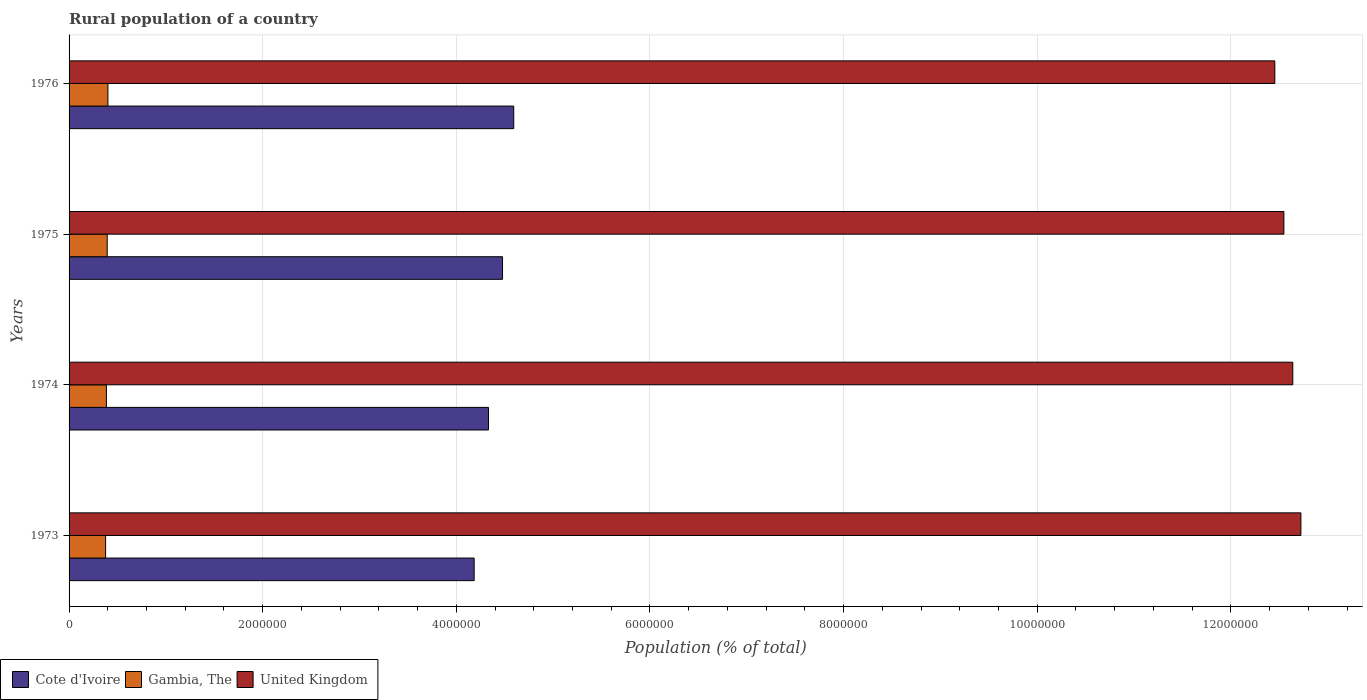How many different coloured bars are there?
Your response must be concise. 3. What is the label of the 3rd group of bars from the top?
Your answer should be very brief. 1974. In how many cases, is the number of bars for a given year not equal to the number of legend labels?
Make the answer very short. 0. What is the rural population in United Kingdom in 1976?
Your response must be concise. 1.25e+07. Across all years, what is the maximum rural population in United Kingdom?
Provide a short and direct response. 1.27e+07. Across all years, what is the minimum rural population in United Kingdom?
Your answer should be compact. 1.25e+07. In which year was the rural population in Cote d'Ivoire maximum?
Give a very brief answer. 1976. What is the total rural population in Gambia, The in the graph?
Provide a short and direct response. 1.56e+06. What is the difference between the rural population in Gambia, The in 1973 and that in 1975?
Offer a very short reply. -1.63e+04. What is the difference between the rural population in Gambia, The in 1976 and the rural population in United Kingdom in 1974?
Your answer should be compact. -1.22e+07. What is the average rural population in Gambia, The per year?
Provide a short and direct response. 3.90e+05. In the year 1976, what is the difference between the rural population in Cote d'Ivoire and rural population in Gambia, The?
Offer a terse response. 4.19e+06. In how many years, is the rural population in Cote d'Ivoire greater than 4800000 %?
Give a very brief answer. 0. What is the ratio of the rural population in Gambia, The in 1973 to that in 1975?
Your answer should be compact. 0.96. Is the rural population in United Kingdom in 1974 less than that in 1976?
Make the answer very short. No. Is the difference between the rural population in Cote d'Ivoire in 1973 and 1976 greater than the difference between the rural population in Gambia, The in 1973 and 1976?
Offer a very short reply. No. What is the difference between the highest and the second highest rural population in Cote d'Ivoire?
Your answer should be very brief. 1.16e+05. What is the difference between the highest and the lowest rural population in United Kingdom?
Keep it short and to the point. 2.69e+05. What does the 2nd bar from the top in 1974 represents?
Give a very brief answer. Gambia, The. What does the 2nd bar from the bottom in 1976 represents?
Keep it short and to the point. Gambia, The. Are all the bars in the graph horizontal?
Make the answer very short. Yes. What is the difference between two consecutive major ticks on the X-axis?
Provide a succinct answer. 2.00e+06. Does the graph contain grids?
Provide a succinct answer. Yes. Where does the legend appear in the graph?
Your response must be concise. Bottom left. How many legend labels are there?
Keep it short and to the point. 3. How are the legend labels stacked?
Offer a very short reply. Horizontal. What is the title of the graph?
Your answer should be very brief. Rural population of a country. What is the label or title of the X-axis?
Ensure brevity in your answer.  Population (% of total). What is the label or title of the Y-axis?
Offer a terse response. Years. What is the Population (% of total) in Cote d'Ivoire in 1973?
Your answer should be very brief. 4.18e+06. What is the Population (% of total) of Gambia, The in 1973?
Ensure brevity in your answer.  3.77e+05. What is the Population (% of total) in United Kingdom in 1973?
Offer a very short reply. 1.27e+07. What is the Population (% of total) of Cote d'Ivoire in 1974?
Make the answer very short. 4.33e+06. What is the Population (% of total) in Gambia, The in 1974?
Keep it short and to the point. 3.86e+05. What is the Population (% of total) of United Kingdom in 1974?
Make the answer very short. 1.26e+07. What is the Population (% of total) of Cote d'Ivoire in 1975?
Ensure brevity in your answer.  4.48e+06. What is the Population (% of total) in Gambia, The in 1975?
Give a very brief answer. 3.94e+05. What is the Population (% of total) of United Kingdom in 1975?
Give a very brief answer. 1.25e+07. What is the Population (% of total) of Cote d'Ivoire in 1976?
Offer a very short reply. 4.59e+06. What is the Population (% of total) in Gambia, The in 1976?
Offer a terse response. 4.01e+05. What is the Population (% of total) of United Kingdom in 1976?
Offer a very short reply. 1.25e+07. Across all years, what is the maximum Population (% of total) in Cote d'Ivoire?
Give a very brief answer. 4.59e+06. Across all years, what is the maximum Population (% of total) of Gambia, The?
Your answer should be compact. 4.01e+05. Across all years, what is the maximum Population (% of total) of United Kingdom?
Your answer should be compact. 1.27e+07. Across all years, what is the minimum Population (% of total) in Cote d'Ivoire?
Make the answer very short. 4.18e+06. Across all years, what is the minimum Population (% of total) of Gambia, The?
Provide a succinct answer. 3.77e+05. Across all years, what is the minimum Population (% of total) in United Kingdom?
Provide a succinct answer. 1.25e+07. What is the total Population (% of total) of Cote d'Ivoire in the graph?
Your answer should be very brief. 1.76e+07. What is the total Population (% of total) of Gambia, The in the graph?
Provide a succinct answer. 1.56e+06. What is the total Population (% of total) in United Kingdom in the graph?
Your answer should be very brief. 5.04e+07. What is the difference between the Population (% of total) in Cote d'Ivoire in 1973 and that in 1974?
Ensure brevity in your answer.  -1.48e+05. What is the difference between the Population (% of total) of Gambia, The in 1973 and that in 1974?
Offer a very short reply. -8351. What is the difference between the Population (% of total) of United Kingdom in 1973 and that in 1974?
Keep it short and to the point. 8.36e+04. What is the difference between the Population (% of total) of Cote d'Ivoire in 1973 and that in 1975?
Provide a succinct answer. -2.93e+05. What is the difference between the Population (% of total) of Gambia, The in 1973 and that in 1975?
Make the answer very short. -1.63e+04. What is the difference between the Population (% of total) of United Kingdom in 1973 and that in 1975?
Offer a very short reply. 1.76e+05. What is the difference between the Population (% of total) in Cote d'Ivoire in 1973 and that in 1976?
Make the answer very short. -4.09e+05. What is the difference between the Population (% of total) of Gambia, The in 1973 and that in 1976?
Your answer should be compact. -2.38e+04. What is the difference between the Population (% of total) of United Kingdom in 1973 and that in 1976?
Your answer should be compact. 2.69e+05. What is the difference between the Population (% of total) in Cote d'Ivoire in 1974 and that in 1975?
Provide a succinct answer. -1.45e+05. What is the difference between the Population (% of total) in Gambia, The in 1974 and that in 1975?
Offer a very short reply. -7961. What is the difference between the Population (% of total) of United Kingdom in 1974 and that in 1975?
Provide a short and direct response. 9.20e+04. What is the difference between the Population (% of total) in Cote d'Ivoire in 1974 and that in 1976?
Ensure brevity in your answer.  -2.61e+05. What is the difference between the Population (% of total) of Gambia, The in 1974 and that in 1976?
Offer a very short reply. -1.54e+04. What is the difference between the Population (% of total) in United Kingdom in 1974 and that in 1976?
Make the answer very short. 1.86e+05. What is the difference between the Population (% of total) in Cote d'Ivoire in 1975 and that in 1976?
Your response must be concise. -1.16e+05. What is the difference between the Population (% of total) in Gambia, The in 1975 and that in 1976?
Provide a short and direct response. -7478. What is the difference between the Population (% of total) in United Kingdom in 1975 and that in 1976?
Make the answer very short. 9.36e+04. What is the difference between the Population (% of total) of Cote d'Ivoire in 1973 and the Population (% of total) of Gambia, The in 1974?
Ensure brevity in your answer.  3.80e+06. What is the difference between the Population (% of total) in Cote d'Ivoire in 1973 and the Population (% of total) in United Kingdom in 1974?
Your answer should be compact. -8.46e+06. What is the difference between the Population (% of total) of Gambia, The in 1973 and the Population (% of total) of United Kingdom in 1974?
Ensure brevity in your answer.  -1.23e+07. What is the difference between the Population (% of total) in Cote d'Ivoire in 1973 and the Population (% of total) in Gambia, The in 1975?
Give a very brief answer. 3.79e+06. What is the difference between the Population (% of total) in Cote d'Ivoire in 1973 and the Population (% of total) in United Kingdom in 1975?
Your answer should be very brief. -8.36e+06. What is the difference between the Population (% of total) in Gambia, The in 1973 and the Population (% of total) in United Kingdom in 1975?
Make the answer very short. -1.22e+07. What is the difference between the Population (% of total) in Cote d'Ivoire in 1973 and the Population (% of total) in Gambia, The in 1976?
Your response must be concise. 3.78e+06. What is the difference between the Population (% of total) of Cote d'Ivoire in 1973 and the Population (% of total) of United Kingdom in 1976?
Your answer should be compact. -8.27e+06. What is the difference between the Population (% of total) in Gambia, The in 1973 and the Population (% of total) in United Kingdom in 1976?
Your answer should be compact. -1.21e+07. What is the difference between the Population (% of total) in Cote d'Ivoire in 1974 and the Population (% of total) in Gambia, The in 1975?
Offer a terse response. 3.94e+06. What is the difference between the Population (% of total) of Cote d'Ivoire in 1974 and the Population (% of total) of United Kingdom in 1975?
Provide a succinct answer. -8.22e+06. What is the difference between the Population (% of total) of Gambia, The in 1974 and the Population (% of total) of United Kingdom in 1975?
Keep it short and to the point. -1.22e+07. What is the difference between the Population (% of total) in Cote d'Ivoire in 1974 and the Population (% of total) in Gambia, The in 1976?
Provide a succinct answer. 3.93e+06. What is the difference between the Population (% of total) in Cote d'Ivoire in 1974 and the Population (% of total) in United Kingdom in 1976?
Your answer should be very brief. -8.12e+06. What is the difference between the Population (% of total) of Gambia, The in 1974 and the Population (% of total) of United Kingdom in 1976?
Provide a succinct answer. -1.21e+07. What is the difference between the Population (% of total) in Cote d'Ivoire in 1975 and the Population (% of total) in Gambia, The in 1976?
Offer a terse response. 4.08e+06. What is the difference between the Population (% of total) in Cote d'Ivoire in 1975 and the Population (% of total) in United Kingdom in 1976?
Your answer should be compact. -7.98e+06. What is the difference between the Population (% of total) of Gambia, The in 1975 and the Population (% of total) of United Kingdom in 1976?
Your response must be concise. -1.21e+07. What is the average Population (% of total) in Cote d'Ivoire per year?
Offer a terse response. 4.40e+06. What is the average Population (% of total) of Gambia, The per year?
Ensure brevity in your answer.  3.90e+05. What is the average Population (% of total) of United Kingdom per year?
Provide a short and direct response. 1.26e+07. In the year 1973, what is the difference between the Population (% of total) in Cote d'Ivoire and Population (% of total) in Gambia, The?
Your answer should be very brief. 3.81e+06. In the year 1973, what is the difference between the Population (% of total) of Cote d'Ivoire and Population (% of total) of United Kingdom?
Keep it short and to the point. -8.54e+06. In the year 1973, what is the difference between the Population (% of total) in Gambia, The and Population (% of total) in United Kingdom?
Your answer should be compact. -1.23e+07. In the year 1974, what is the difference between the Population (% of total) of Cote d'Ivoire and Population (% of total) of Gambia, The?
Ensure brevity in your answer.  3.95e+06. In the year 1974, what is the difference between the Population (% of total) of Cote d'Ivoire and Population (% of total) of United Kingdom?
Your response must be concise. -8.31e+06. In the year 1974, what is the difference between the Population (% of total) of Gambia, The and Population (% of total) of United Kingdom?
Offer a terse response. -1.23e+07. In the year 1975, what is the difference between the Population (% of total) of Cote d'Ivoire and Population (% of total) of Gambia, The?
Provide a short and direct response. 4.08e+06. In the year 1975, what is the difference between the Population (% of total) in Cote d'Ivoire and Population (% of total) in United Kingdom?
Give a very brief answer. -8.07e+06. In the year 1975, what is the difference between the Population (% of total) of Gambia, The and Population (% of total) of United Kingdom?
Offer a very short reply. -1.22e+07. In the year 1976, what is the difference between the Population (% of total) in Cote d'Ivoire and Population (% of total) in Gambia, The?
Keep it short and to the point. 4.19e+06. In the year 1976, what is the difference between the Population (% of total) in Cote d'Ivoire and Population (% of total) in United Kingdom?
Give a very brief answer. -7.86e+06. In the year 1976, what is the difference between the Population (% of total) of Gambia, The and Population (% of total) of United Kingdom?
Your answer should be very brief. -1.21e+07. What is the ratio of the Population (% of total) of Cote d'Ivoire in 1973 to that in 1974?
Provide a succinct answer. 0.97. What is the ratio of the Population (% of total) in Gambia, The in 1973 to that in 1974?
Ensure brevity in your answer.  0.98. What is the ratio of the Population (% of total) in United Kingdom in 1973 to that in 1974?
Ensure brevity in your answer.  1.01. What is the ratio of the Population (% of total) of Cote d'Ivoire in 1973 to that in 1975?
Keep it short and to the point. 0.93. What is the ratio of the Population (% of total) of Gambia, The in 1973 to that in 1975?
Offer a terse response. 0.96. What is the ratio of the Population (% of total) of Cote d'Ivoire in 1973 to that in 1976?
Your response must be concise. 0.91. What is the ratio of the Population (% of total) of Gambia, The in 1973 to that in 1976?
Offer a terse response. 0.94. What is the ratio of the Population (% of total) in United Kingdom in 1973 to that in 1976?
Your answer should be compact. 1.02. What is the ratio of the Population (% of total) in Cote d'Ivoire in 1974 to that in 1975?
Offer a very short reply. 0.97. What is the ratio of the Population (% of total) of Gambia, The in 1974 to that in 1975?
Keep it short and to the point. 0.98. What is the ratio of the Population (% of total) in United Kingdom in 1974 to that in 1975?
Your response must be concise. 1.01. What is the ratio of the Population (% of total) of Cote d'Ivoire in 1974 to that in 1976?
Your response must be concise. 0.94. What is the ratio of the Population (% of total) in Gambia, The in 1974 to that in 1976?
Give a very brief answer. 0.96. What is the ratio of the Population (% of total) of United Kingdom in 1974 to that in 1976?
Offer a very short reply. 1.01. What is the ratio of the Population (% of total) in Cote d'Ivoire in 1975 to that in 1976?
Your answer should be compact. 0.97. What is the ratio of the Population (% of total) in Gambia, The in 1975 to that in 1976?
Give a very brief answer. 0.98. What is the ratio of the Population (% of total) of United Kingdom in 1975 to that in 1976?
Give a very brief answer. 1.01. What is the difference between the highest and the second highest Population (% of total) in Cote d'Ivoire?
Give a very brief answer. 1.16e+05. What is the difference between the highest and the second highest Population (% of total) of Gambia, The?
Your answer should be very brief. 7478. What is the difference between the highest and the second highest Population (% of total) of United Kingdom?
Your response must be concise. 8.36e+04. What is the difference between the highest and the lowest Population (% of total) in Cote d'Ivoire?
Offer a terse response. 4.09e+05. What is the difference between the highest and the lowest Population (% of total) of Gambia, The?
Offer a terse response. 2.38e+04. What is the difference between the highest and the lowest Population (% of total) in United Kingdom?
Offer a terse response. 2.69e+05. 